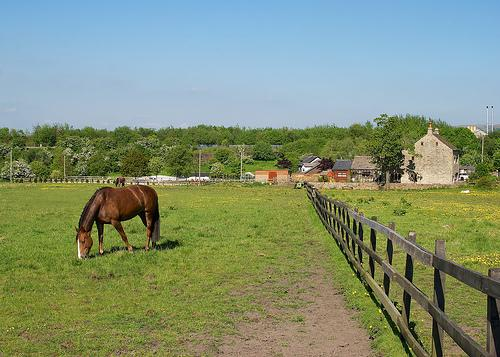What is the main animal in the image and what is it doing? A brown and white horse is grazing on the grass in a field. Describe the weather and sky in the image. The sky is clear and blue with white clouds scattered throughout. Describe the setting in which the image takes place. The image takes place in a grass and dirt field with fences, trees, buildings, and a hillside in the background, under a clear blue sky. Identify the type of landscape behind the horse. There is a hillside filled with shrubbery, trees, fields strewn with yellow wildflowers, and power lines in the background. Identify the most noticeable feature on the horse's head. The most noticeable feature on the horse's head is a white stripe on its nose. Mention the fencing in the image and its characteristics. There is a wooden fence, post and board fencing, and a fence dividing the pasture land, as well as a wooden fence post. Count the number of utility poles in the image. There are four utility poles in a line. What type of interaction is happening between the horse and its environment? The horse is grazing on the grass and casting a shadow on the ground in the field, interacting with the surrounding environment. Discuss the state of the grass that the horse is on. The grass has dirt patches, a bare patch, and yellow flowers mixed in. What type of building is in the background, and describe its features. There is a stucco building with two tiny windows and sun reflecting on it, as well as a white barn in the background. Based on the descriptions, how would you rate the image's overall quality on a scale from 1 to 5, with 5 being the best quality? 4 Can you find the blue flowers in the grass surrounding the horse? No, it's not mentioned in the image. Count the number of white clouds mentioned in the image. 9 Describe the main features of the image. A brown and white horse grazing in a grass field with wooden fences, yellow wildflowers, farm buildings, and blue sky with white clouds. Are there any notable yellow objects in the image? Yes, yellow flowers in the grass with coordinates X:480, Y:258, Width:17, Height:17 Do the trees cast any shadows in the image? No shadows from the trees Identify the color of the horse's nose stripe. white What is the color of the sky in the image? Blue with white clouds Describe the area surrounding the horse. Grass field with wooden fences, yellow wildflowers, farm buildings, trees, power lines, and blue sky with white clouds. What type of fencing is present in the image? Wooden fence, post, and board fencing Is there a line of more than three utility poles present in the image? Yes, line of four utility poles with coordinates X:7, Y:146, Width:237, Height:237 Do power lines appear in the background of the image? Yes, power lines in the background with coordinates X:221, Y:128, Width:67, Height:67 Estimate the position (X, Y), width, and height of the horse's head. X:75, Y:228, Width:15, Height:15 In the image, is there a noticeable shadow on any object? Yes, shadow on the wood with coordinates X:407, Y:260, Width:5, Height:5. Determine if any large patches of dirt can be seen in the image. Yes, dirt patch in the pasture with coordinates X:188, Y:251, Width:190, Height:190 How many white windows can be seen on the building in the image? Two white windows with coordinates X:338, Y:171, Width:10, Height:10 What is the predominant color of the grass in the image? Green What object has dirt on it in the image? Grass with coordinates X:205, Y:239, Width:207, Height:207 Detect any objects interacting with the horse in the field. There's no direct interaction, but the horse is browsing with the grass. What is the sentiment of the image with the horse, fences, and farm buildings? Positive Find the hillside covered with vegetation in the image. Hillside filled with shrubbery at coordinates X:3, Y:111, Width:495, Height:495 